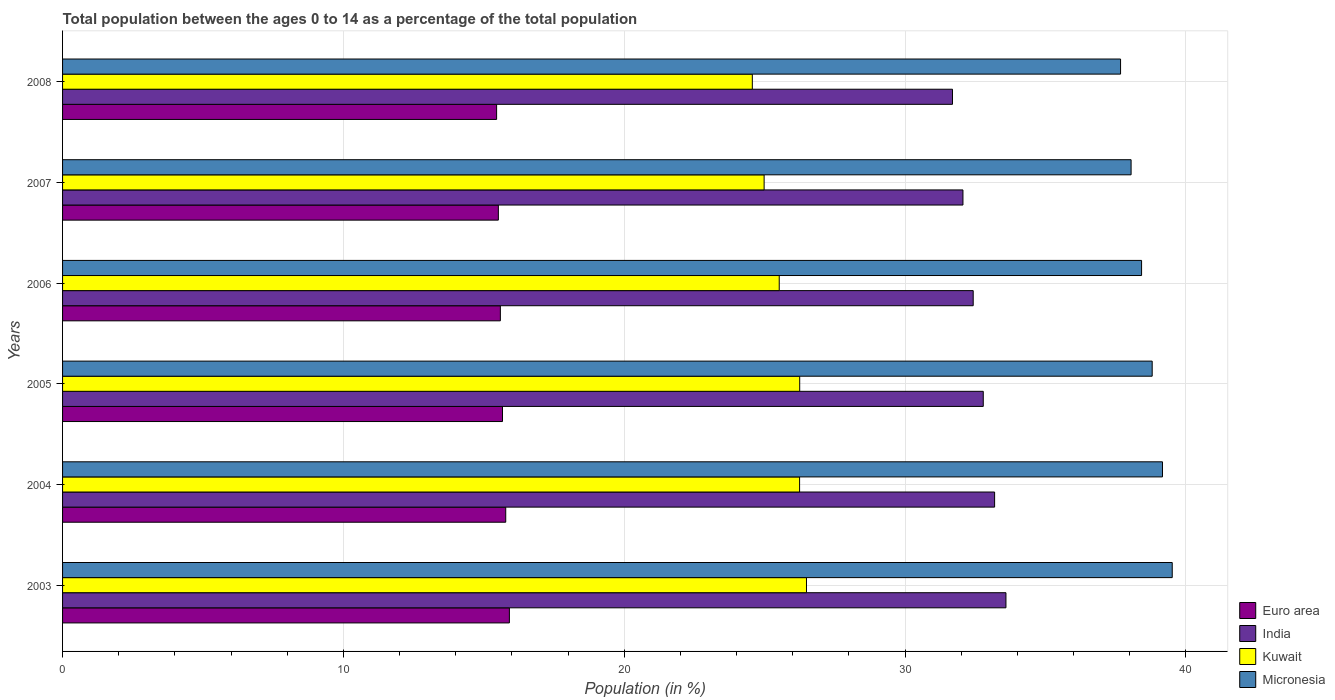How many different coloured bars are there?
Give a very brief answer. 4. How many groups of bars are there?
Keep it short and to the point. 6. Are the number of bars on each tick of the Y-axis equal?
Your answer should be compact. Yes. What is the label of the 6th group of bars from the top?
Your answer should be very brief. 2003. In how many cases, is the number of bars for a given year not equal to the number of legend labels?
Your answer should be compact. 0. What is the percentage of the population ages 0 to 14 in Euro area in 2003?
Ensure brevity in your answer.  15.91. Across all years, what is the maximum percentage of the population ages 0 to 14 in Euro area?
Ensure brevity in your answer.  15.91. Across all years, what is the minimum percentage of the population ages 0 to 14 in Kuwait?
Provide a succinct answer. 24.56. In which year was the percentage of the population ages 0 to 14 in Kuwait minimum?
Make the answer very short. 2008. What is the total percentage of the population ages 0 to 14 in Kuwait in the graph?
Your answer should be very brief. 154.05. What is the difference between the percentage of the population ages 0 to 14 in Euro area in 2004 and that in 2005?
Provide a succinct answer. 0.12. What is the difference between the percentage of the population ages 0 to 14 in Euro area in 2005 and the percentage of the population ages 0 to 14 in India in 2003?
Your answer should be very brief. -17.93. What is the average percentage of the population ages 0 to 14 in India per year?
Your answer should be compact. 32.62. In the year 2008, what is the difference between the percentage of the population ages 0 to 14 in India and percentage of the population ages 0 to 14 in Kuwait?
Keep it short and to the point. 7.13. In how many years, is the percentage of the population ages 0 to 14 in Kuwait greater than 4 ?
Your response must be concise. 6. What is the ratio of the percentage of the population ages 0 to 14 in Euro area in 2007 to that in 2008?
Your response must be concise. 1. Is the percentage of the population ages 0 to 14 in Euro area in 2003 less than that in 2004?
Give a very brief answer. No. What is the difference between the highest and the second highest percentage of the population ages 0 to 14 in Kuwait?
Provide a succinct answer. 0.24. What is the difference between the highest and the lowest percentage of the population ages 0 to 14 in India?
Keep it short and to the point. 1.9. Is it the case that in every year, the sum of the percentage of the population ages 0 to 14 in Kuwait and percentage of the population ages 0 to 14 in Euro area is greater than the sum of percentage of the population ages 0 to 14 in India and percentage of the population ages 0 to 14 in Micronesia?
Your answer should be very brief. No. What does the 2nd bar from the top in 2006 represents?
Provide a succinct answer. Kuwait. What does the 4th bar from the bottom in 2005 represents?
Provide a succinct answer. Micronesia. How many bars are there?
Offer a very short reply. 24. Are all the bars in the graph horizontal?
Ensure brevity in your answer.  Yes. What is the difference between two consecutive major ticks on the X-axis?
Offer a very short reply. 10. Does the graph contain any zero values?
Offer a very short reply. No. What is the title of the graph?
Provide a short and direct response. Total population between the ages 0 to 14 as a percentage of the total population. What is the Population (in %) in Euro area in 2003?
Ensure brevity in your answer.  15.91. What is the Population (in %) of India in 2003?
Offer a very short reply. 33.59. What is the Population (in %) of Kuwait in 2003?
Offer a very short reply. 26.49. What is the Population (in %) in Micronesia in 2003?
Your response must be concise. 39.51. What is the Population (in %) of Euro area in 2004?
Offer a terse response. 15.78. What is the Population (in %) in India in 2004?
Keep it short and to the point. 33.19. What is the Population (in %) of Kuwait in 2004?
Provide a short and direct response. 26.24. What is the Population (in %) in Micronesia in 2004?
Offer a terse response. 39.17. What is the Population (in %) in Euro area in 2005?
Ensure brevity in your answer.  15.67. What is the Population (in %) of India in 2005?
Provide a succinct answer. 32.78. What is the Population (in %) of Kuwait in 2005?
Provide a short and direct response. 26.25. What is the Population (in %) of Micronesia in 2005?
Make the answer very short. 38.8. What is the Population (in %) of Euro area in 2006?
Give a very brief answer. 15.59. What is the Population (in %) of India in 2006?
Provide a succinct answer. 32.43. What is the Population (in %) of Kuwait in 2006?
Your response must be concise. 25.52. What is the Population (in %) of Micronesia in 2006?
Give a very brief answer. 38.42. What is the Population (in %) of Euro area in 2007?
Ensure brevity in your answer.  15.52. What is the Population (in %) in India in 2007?
Provide a succinct answer. 32.06. What is the Population (in %) in Kuwait in 2007?
Ensure brevity in your answer.  24.98. What is the Population (in %) in Micronesia in 2007?
Offer a terse response. 38.05. What is the Population (in %) in Euro area in 2008?
Your answer should be very brief. 15.46. What is the Population (in %) of India in 2008?
Ensure brevity in your answer.  31.69. What is the Population (in %) of Kuwait in 2008?
Keep it short and to the point. 24.56. What is the Population (in %) of Micronesia in 2008?
Offer a terse response. 37.67. Across all years, what is the maximum Population (in %) of Euro area?
Ensure brevity in your answer.  15.91. Across all years, what is the maximum Population (in %) in India?
Provide a succinct answer. 33.59. Across all years, what is the maximum Population (in %) in Kuwait?
Ensure brevity in your answer.  26.49. Across all years, what is the maximum Population (in %) of Micronesia?
Offer a terse response. 39.51. Across all years, what is the minimum Population (in %) of Euro area?
Your response must be concise. 15.46. Across all years, what is the minimum Population (in %) of India?
Ensure brevity in your answer.  31.69. Across all years, what is the minimum Population (in %) in Kuwait?
Offer a very short reply. 24.56. Across all years, what is the minimum Population (in %) of Micronesia?
Provide a short and direct response. 37.67. What is the total Population (in %) in Euro area in the graph?
Offer a very short reply. 93.92. What is the total Population (in %) in India in the graph?
Provide a succinct answer. 195.74. What is the total Population (in %) of Kuwait in the graph?
Provide a short and direct response. 154.05. What is the total Population (in %) in Micronesia in the graph?
Ensure brevity in your answer.  231.63. What is the difference between the Population (in %) in Euro area in 2003 and that in 2004?
Your response must be concise. 0.13. What is the difference between the Population (in %) in India in 2003 and that in 2004?
Make the answer very short. 0.4. What is the difference between the Population (in %) in Kuwait in 2003 and that in 2004?
Offer a very short reply. 0.25. What is the difference between the Population (in %) of Micronesia in 2003 and that in 2004?
Provide a short and direct response. 0.35. What is the difference between the Population (in %) in Euro area in 2003 and that in 2005?
Provide a succinct answer. 0.25. What is the difference between the Population (in %) in India in 2003 and that in 2005?
Keep it short and to the point. 0.81. What is the difference between the Population (in %) of Kuwait in 2003 and that in 2005?
Provide a succinct answer. 0.24. What is the difference between the Population (in %) of Micronesia in 2003 and that in 2005?
Provide a succinct answer. 0.71. What is the difference between the Population (in %) of Euro area in 2003 and that in 2006?
Provide a short and direct response. 0.32. What is the difference between the Population (in %) in India in 2003 and that in 2006?
Your answer should be very brief. 1.17. What is the difference between the Population (in %) in Kuwait in 2003 and that in 2006?
Give a very brief answer. 0.97. What is the difference between the Population (in %) of Micronesia in 2003 and that in 2006?
Provide a succinct answer. 1.09. What is the difference between the Population (in %) of Euro area in 2003 and that in 2007?
Ensure brevity in your answer.  0.39. What is the difference between the Population (in %) in India in 2003 and that in 2007?
Give a very brief answer. 1.53. What is the difference between the Population (in %) of Kuwait in 2003 and that in 2007?
Ensure brevity in your answer.  1.51. What is the difference between the Population (in %) of Micronesia in 2003 and that in 2007?
Provide a short and direct response. 1.46. What is the difference between the Population (in %) of Euro area in 2003 and that in 2008?
Your answer should be very brief. 0.46. What is the difference between the Population (in %) of India in 2003 and that in 2008?
Provide a short and direct response. 1.9. What is the difference between the Population (in %) in Kuwait in 2003 and that in 2008?
Provide a succinct answer. 1.93. What is the difference between the Population (in %) in Micronesia in 2003 and that in 2008?
Your response must be concise. 1.84. What is the difference between the Population (in %) in Euro area in 2004 and that in 2005?
Make the answer very short. 0.12. What is the difference between the Population (in %) of India in 2004 and that in 2005?
Your answer should be compact. 0.4. What is the difference between the Population (in %) in Kuwait in 2004 and that in 2005?
Your response must be concise. -0. What is the difference between the Population (in %) of Micronesia in 2004 and that in 2005?
Offer a terse response. 0.37. What is the difference between the Population (in %) of Euro area in 2004 and that in 2006?
Give a very brief answer. 0.19. What is the difference between the Population (in %) of India in 2004 and that in 2006?
Offer a very short reply. 0.76. What is the difference between the Population (in %) in Kuwait in 2004 and that in 2006?
Your response must be concise. 0.73. What is the difference between the Population (in %) in Micronesia in 2004 and that in 2006?
Offer a very short reply. 0.74. What is the difference between the Population (in %) in Euro area in 2004 and that in 2007?
Keep it short and to the point. 0.26. What is the difference between the Population (in %) of India in 2004 and that in 2007?
Provide a succinct answer. 1.13. What is the difference between the Population (in %) of Kuwait in 2004 and that in 2007?
Keep it short and to the point. 1.26. What is the difference between the Population (in %) of Micronesia in 2004 and that in 2007?
Offer a terse response. 1.12. What is the difference between the Population (in %) of Euro area in 2004 and that in 2008?
Provide a succinct answer. 0.33. What is the difference between the Population (in %) in India in 2004 and that in 2008?
Your answer should be compact. 1.5. What is the difference between the Population (in %) in Kuwait in 2004 and that in 2008?
Your answer should be compact. 1.68. What is the difference between the Population (in %) of Micronesia in 2004 and that in 2008?
Make the answer very short. 1.49. What is the difference between the Population (in %) in Euro area in 2005 and that in 2006?
Offer a terse response. 0.08. What is the difference between the Population (in %) of India in 2005 and that in 2006?
Your response must be concise. 0.36. What is the difference between the Population (in %) in Kuwait in 2005 and that in 2006?
Your answer should be very brief. 0.73. What is the difference between the Population (in %) of Micronesia in 2005 and that in 2006?
Offer a terse response. 0.38. What is the difference between the Population (in %) of Euro area in 2005 and that in 2007?
Make the answer very short. 0.15. What is the difference between the Population (in %) in India in 2005 and that in 2007?
Your answer should be very brief. 0.72. What is the difference between the Population (in %) in Kuwait in 2005 and that in 2007?
Keep it short and to the point. 1.27. What is the difference between the Population (in %) of Micronesia in 2005 and that in 2007?
Offer a terse response. 0.75. What is the difference between the Population (in %) of Euro area in 2005 and that in 2008?
Your answer should be compact. 0.21. What is the difference between the Population (in %) of India in 2005 and that in 2008?
Your response must be concise. 1.1. What is the difference between the Population (in %) in Kuwait in 2005 and that in 2008?
Ensure brevity in your answer.  1.69. What is the difference between the Population (in %) of Micronesia in 2005 and that in 2008?
Give a very brief answer. 1.13. What is the difference between the Population (in %) of Euro area in 2006 and that in 2007?
Your answer should be very brief. 0.07. What is the difference between the Population (in %) of India in 2006 and that in 2007?
Offer a terse response. 0.36. What is the difference between the Population (in %) of Kuwait in 2006 and that in 2007?
Your answer should be very brief. 0.54. What is the difference between the Population (in %) of Micronesia in 2006 and that in 2007?
Provide a succinct answer. 0.37. What is the difference between the Population (in %) in Euro area in 2006 and that in 2008?
Offer a very short reply. 0.13. What is the difference between the Population (in %) in India in 2006 and that in 2008?
Offer a terse response. 0.74. What is the difference between the Population (in %) in Kuwait in 2006 and that in 2008?
Ensure brevity in your answer.  0.96. What is the difference between the Population (in %) of Micronesia in 2006 and that in 2008?
Offer a terse response. 0.75. What is the difference between the Population (in %) of Euro area in 2007 and that in 2008?
Your answer should be compact. 0.06. What is the difference between the Population (in %) in India in 2007 and that in 2008?
Your answer should be very brief. 0.37. What is the difference between the Population (in %) of Kuwait in 2007 and that in 2008?
Keep it short and to the point. 0.42. What is the difference between the Population (in %) of Micronesia in 2007 and that in 2008?
Provide a succinct answer. 0.37. What is the difference between the Population (in %) in Euro area in 2003 and the Population (in %) in India in 2004?
Provide a succinct answer. -17.28. What is the difference between the Population (in %) in Euro area in 2003 and the Population (in %) in Kuwait in 2004?
Offer a very short reply. -10.33. What is the difference between the Population (in %) of Euro area in 2003 and the Population (in %) of Micronesia in 2004?
Provide a succinct answer. -23.26. What is the difference between the Population (in %) of India in 2003 and the Population (in %) of Kuwait in 2004?
Your answer should be compact. 7.35. What is the difference between the Population (in %) of India in 2003 and the Population (in %) of Micronesia in 2004?
Provide a succinct answer. -5.57. What is the difference between the Population (in %) in Kuwait in 2003 and the Population (in %) in Micronesia in 2004?
Your answer should be compact. -12.68. What is the difference between the Population (in %) in Euro area in 2003 and the Population (in %) in India in 2005?
Provide a short and direct response. -16.87. What is the difference between the Population (in %) in Euro area in 2003 and the Population (in %) in Kuwait in 2005?
Your response must be concise. -10.34. What is the difference between the Population (in %) in Euro area in 2003 and the Population (in %) in Micronesia in 2005?
Keep it short and to the point. -22.89. What is the difference between the Population (in %) of India in 2003 and the Population (in %) of Kuwait in 2005?
Keep it short and to the point. 7.34. What is the difference between the Population (in %) of India in 2003 and the Population (in %) of Micronesia in 2005?
Keep it short and to the point. -5.21. What is the difference between the Population (in %) in Kuwait in 2003 and the Population (in %) in Micronesia in 2005?
Offer a very short reply. -12.31. What is the difference between the Population (in %) of Euro area in 2003 and the Population (in %) of India in 2006?
Ensure brevity in your answer.  -16.52. What is the difference between the Population (in %) in Euro area in 2003 and the Population (in %) in Kuwait in 2006?
Provide a succinct answer. -9.61. What is the difference between the Population (in %) of Euro area in 2003 and the Population (in %) of Micronesia in 2006?
Offer a very short reply. -22.51. What is the difference between the Population (in %) of India in 2003 and the Population (in %) of Kuwait in 2006?
Your answer should be very brief. 8.07. What is the difference between the Population (in %) of India in 2003 and the Population (in %) of Micronesia in 2006?
Your answer should be compact. -4.83. What is the difference between the Population (in %) in Kuwait in 2003 and the Population (in %) in Micronesia in 2006?
Your answer should be very brief. -11.93. What is the difference between the Population (in %) in Euro area in 2003 and the Population (in %) in India in 2007?
Provide a short and direct response. -16.15. What is the difference between the Population (in %) in Euro area in 2003 and the Population (in %) in Kuwait in 2007?
Make the answer very short. -9.07. What is the difference between the Population (in %) of Euro area in 2003 and the Population (in %) of Micronesia in 2007?
Give a very brief answer. -22.14. What is the difference between the Population (in %) in India in 2003 and the Population (in %) in Kuwait in 2007?
Make the answer very short. 8.61. What is the difference between the Population (in %) in India in 2003 and the Population (in %) in Micronesia in 2007?
Your answer should be compact. -4.46. What is the difference between the Population (in %) in Kuwait in 2003 and the Population (in %) in Micronesia in 2007?
Ensure brevity in your answer.  -11.56. What is the difference between the Population (in %) in Euro area in 2003 and the Population (in %) in India in 2008?
Provide a succinct answer. -15.78. What is the difference between the Population (in %) of Euro area in 2003 and the Population (in %) of Kuwait in 2008?
Your answer should be compact. -8.65. What is the difference between the Population (in %) of Euro area in 2003 and the Population (in %) of Micronesia in 2008?
Your answer should be very brief. -21.76. What is the difference between the Population (in %) in India in 2003 and the Population (in %) in Kuwait in 2008?
Provide a succinct answer. 9.03. What is the difference between the Population (in %) in India in 2003 and the Population (in %) in Micronesia in 2008?
Provide a short and direct response. -4.08. What is the difference between the Population (in %) of Kuwait in 2003 and the Population (in %) of Micronesia in 2008?
Make the answer very short. -11.18. What is the difference between the Population (in %) of Euro area in 2004 and the Population (in %) of India in 2005?
Your response must be concise. -17. What is the difference between the Population (in %) in Euro area in 2004 and the Population (in %) in Kuwait in 2005?
Offer a terse response. -10.47. What is the difference between the Population (in %) in Euro area in 2004 and the Population (in %) in Micronesia in 2005?
Give a very brief answer. -23.02. What is the difference between the Population (in %) in India in 2004 and the Population (in %) in Kuwait in 2005?
Your answer should be compact. 6.94. What is the difference between the Population (in %) in India in 2004 and the Population (in %) in Micronesia in 2005?
Your answer should be very brief. -5.61. What is the difference between the Population (in %) in Kuwait in 2004 and the Population (in %) in Micronesia in 2005?
Keep it short and to the point. -12.56. What is the difference between the Population (in %) of Euro area in 2004 and the Population (in %) of India in 2006?
Give a very brief answer. -16.65. What is the difference between the Population (in %) in Euro area in 2004 and the Population (in %) in Kuwait in 2006?
Provide a succinct answer. -9.74. What is the difference between the Population (in %) in Euro area in 2004 and the Population (in %) in Micronesia in 2006?
Your answer should be very brief. -22.64. What is the difference between the Population (in %) in India in 2004 and the Population (in %) in Kuwait in 2006?
Give a very brief answer. 7.67. What is the difference between the Population (in %) in India in 2004 and the Population (in %) in Micronesia in 2006?
Give a very brief answer. -5.23. What is the difference between the Population (in %) of Kuwait in 2004 and the Population (in %) of Micronesia in 2006?
Ensure brevity in your answer.  -12.18. What is the difference between the Population (in %) in Euro area in 2004 and the Population (in %) in India in 2007?
Your answer should be compact. -16.28. What is the difference between the Population (in %) of Euro area in 2004 and the Population (in %) of Kuwait in 2007?
Give a very brief answer. -9.2. What is the difference between the Population (in %) of Euro area in 2004 and the Population (in %) of Micronesia in 2007?
Keep it short and to the point. -22.27. What is the difference between the Population (in %) of India in 2004 and the Population (in %) of Kuwait in 2007?
Your answer should be compact. 8.21. What is the difference between the Population (in %) in India in 2004 and the Population (in %) in Micronesia in 2007?
Your response must be concise. -4.86. What is the difference between the Population (in %) of Kuwait in 2004 and the Population (in %) of Micronesia in 2007?
Your response must be concise. -11.8. What is the difference between the Population (in %) in Euro area in 2004 and the Population (in %) in India in 2008?
Your answer should be very brief. -15.91. What is the difference between the Population (in %) of Euro area in 2004 and the Population (in %) of Kuwait in 2008?
Ensure brevity in your answer.  -8.78. What is the difference between the Population (in %) of Euro area in 2004 and the Population (in %) of Micronesia in 2008?
Offer a terse response. -21.89. What is the difference between the Population (in %) in India in 2004 and the Population (in %) in Kuwait in 2008?
Ensure brevity in your answer.  8.63. What is the difference between the Population (in %) in India in 2004 and the Population (in %) in Micronesia in 2008?
Make the answer very short. -4.49. What is the difference between the Population (in %) in Kuwait in 2004 and the Population (in %) in Micronesia in 2008?
Provide a short and direct response. -11.43. What is the difference between the Population (in %) in Euro area in 2005 and the Population (in %) in India in 2006?
Offer a very short reply. -16.76. What is the difference between the Population (in %) in Euro area in 2005 and the Population (in %) in Kuwait in 2006?
Keep it short and to the point. -9.85. What is the difference between the Population (in %) of Euro area in 2005 and the Population (in %) of Micronesia in 2006?
Keep it short and to the point. -22.76. What is the difference between the Population (in %) in India in 2005 and the Population (in %) in Kuwait in 2006?
Keep it short and to the point. 7.27. What is the difference between the Population (in %) in India in 2005 and the Population (in %) in Micronesia in 2006?
Offer a terse response. -5.64. What is the difference between the Population (in %) in Kuwait in 2005 and the Population (in %) in Micronesia in 2006?
Keep it short and to the point. -12.17. What is the difference between the Population (in %) in Euro area in 2005 and the Population (in %) in India in 2007?
Offer a very short reply. -16.4. What is the difference between the Population (in %) of Euro area in 2005 and the Population (in %) of Kuwait in 2007?
Provide a short and direct response. -9.32. What is the difference between the Population (in %) of Euro area in 2005 and the Population (in %) of Micronesia in 2007?
Provide a succinct answer. -22.38. What is the difference between the Population (in %) in India in 2005 and the Population (in %) in Kuwait in 2007?
Ensure brevity in your answer.  7.8. What is the difference between the Population (in %) of India in 2005 and the Population (in %) of Micronesia in 2007?
Provide a succinct answer. -5.26. What is the difference between the Population (in %) of Kuwait in 2005 and the Population (in %) of Micronesia in 2007?
Offer a terse response. -11.8. What is the difference between the Population (in %) in Euro area in 2005 and the Population (in %) in India in 2008?
Offer a very short reply. -16.02. What is the difference between the Population (in %) of Euro area in 2005 and the Population (in %) of Kuwait in 2008?
Your answer should be very brief. -8.9. What is the difference between the Population (in %) of Euro area in 2005 and the Population (in %) of Micronesia in 2008?
Your response must be concise. -22.01. What is the difference between the Population (in %) in India in 2005 and the Population (in %) in Kuwait in 2008?
Your response must be concise. 8.22. What is the difference between the Population (in %) in India in 2005 and the Population (in %) in Micronesia in 2008?
Ensure brevity in your answer.  -4.89. What is the difference between the Population (in %) in Kuwait in 2005 and the Population (in %) in Micronesia in 2008?
Keep it short and to the point. -11.43. What is the difference between the Population (in %) in Euro area in 2006 and the Population (in %) in India in 2007?
Offer a terse response. -16.47. What is the difference between the Population (in %) in Euro area in 2006 and the Population (in %) in Kuwait in 2007?
Provide a succinct answer. -9.39. What is the difference between the Population (in %) of Euro area in 2006 and the Population (in %) of Micronesia in 2007?
Make the answer very short. -22.46. What is the difference between the Population (in %) in India in 2006 and the Population (in %) in Kuwait in 2007?
Offer a very short reply. 7.45. What is the difference between the Population (in %) of India in 2006 and the Population (in %) of Micronesia in 2007?
Your answer should be very brief. -5.62. What is the difference between the Population (in %) in Kuwait in 2006 and the Population (in %) in Micronesia in 2007?
Provide a short and direct response. -12.53. What is the difference between the Population (in %) in Euro area in 2006 and the Population (in %) in India in 2008?
Make the answer very short. -16.1. What is the difference between the Population (in %) of Euro area in 2006 and the Population (in %) of Kuwait in 2008?
Offer a terse response. -8.97. What is the difference between the Population (in %) of Euro area in 2006 and the Population (in %) of Micronesia in 2008?
Your answer should be very brief. -22.09. What is the difference between the Population (in %) of India in 2006 and the Population (in %) of Kuwait in 2008?
Provide a short and direct response. 7.87. What is the difference between the Population (in %) of India in 2006 and the Population (in %) of Micronesia in 2008?
Make the answer very short. -5.25. What is the difference between the Population (in %) in Kuwait in 2006 and the Population (in %) in Micronesia in 2008?
Offer a terse response. -12.15. What is the difference between the Population (in %) of Euro area in 2007 and the Population (in %) of India in 2008?
Make the answer very short. -16.17. What is the difference between the Population (in %) in Euro area in 2007 and the Population (in %) in Kuwait in 2008?
Your response must be concise. -9.04. What is the difference between the Population (in %) in Euro area in 2007 and the Population (in %) in Micronesia in 2008?
Offer a very short reply. -22.16. What is the difference between the Population (in %) of India in 2007 and the Population (in %) of Kuwait in 2008?
Your answer should be very brief. 7.5. What is the difference between the Population (in %) of India in 2007 and the Population (in %) of Micronesia in 2008?
Provide a short and direct response. -5.61. What is the difference between the Population (in %) of Kuwait in 2007 and the Population (in %) of Micronesia in 2008?
Provide a succinct answer. -12.69. What is the average Population (in %) of Euro area per year?
Keep it short and to the point. 15.65. What is the average Population (in %) of India per year?
Provide a succinct answer. 32.62. What is the average Population (in %) in Kuwait per year?
Your answer should be compact. 25.67. What is the average Population (in %) in Micronesia per year?
Make the answer very short. 38.6. In the year 2003, what is the difference between the Population (in %) of Euro area and Population (in %) of India?
Give a very brief answer. -17.68. In the year 2003, what is the difference between the Population (in %) of Euro area and Population (in %) of Kuwait?
Offer a very short reply. -10.58. In the year 2003, what is the difference between the Population (in %) in Euro area and Population (in %) in Micronesia?
Provide a short and direct response. -23.6. In the year 2003, what is the difference between the Population (in %) of India and Population (in %) of Kuwait?
Your response must be concise. 7.1. In the year 2003, what is the difference between the Population (in %) of India and Population (in %) of Micronesia?
Your response must be concise. -5.92. In the year 2003, what is the difference between the Population (in %) of Kuwait and Population (in %) of Micronesia?
Offer a terse response. -13.02. In the year 2004, what is the difference between the Population (in %) in Euro area and Population (in %) in India?
Offer a very short reply. -17.41. In the year 2004, what is the difference between the Population (in %) in Euro area and Population (in %) in Kuwait?
Provide a succinct answer. -10.46. In the year 2004, what is the difference between the Population (in %) in Euro area and Population (in %) in Micronesia?
Offer a terse response. -23.39. In the year 2004, what is the difference between the Population (in %) of India and Population (in %) of Kuwait?
Offer a terse response. 6.94. In the year 2004, what is the difference between the Population (in %) in India and Population (in %) in Micronesia?
Keep it short and to the point. -5.98. In the year 2004, what is the difference between the Population (in %) of Kuwait and Population (in %) of Micronesia?
Provide a short and direct response. -12.92. In the year 2005, what is the difference between the Population (in %) in Euro area and Population (in %) in India?
Your answer should be very brief. -17.12. In the year 2005, what is the difference between the Population (in %) of Euro area and Population (in %) of Kuwait?
Offer a very short reply. -10.58. In the year 2005, what is the difference between the Population (in %) in Euro area and Population (in %) in Micronesia?
Your answer should be very brief. -23.13. In the year 2005, what is the difference between the Population (in %) of India and Population (in %) of Kuwait?
Your response must be concise. 6.54. In the year 2005, what is the difference between the Population (in %) in India and Population (in %) in Micronesia?
Offer a very short reply. -6.02. In the year 2005, what is the difference between the Population (in %) in Kuwait and Population (in %) in Micronesia?
Give a very brief answer. -12.55. In the year 2006, what is the difference between the Population (in %) in Euro area and Population (in %) in India?
Your answer should be compact. -16.84. In the year 2006, what is the difference between the Population (in %) in Euro area and Population (in %) in Kuwait?
Provide a short and direct response. -9.93. In the year 2006, what is the difference between the Population (in %) of Euro area and Population (in %) of Micronesia?
Offer a very short reply. -22.83. In the year 2006, what is the difference between the Population (in %) in India and Population (in %) in Kuwait?
Your response must be concise. 6.91. In the year 2006, what is the difference between the Population (in %) of India and Population (in %) of Micronesia?
Provide a succinct answer. -6. In the year 2006, what is the difference between the Population (in %) in Kuwait and Population (in %) in Micronesia?
Your answer should be very brief. -12.9. In the year 2007, what is the difference between the Population (in %) in Euro area and Population (in %) in India?
Give a very brief answer. -16.54. In the year 2007, what is the difference between the Population (in %) of Euro area and Population (in %) of Kuwait?
Offer a terse response. -9.46. In the year 2007, what is the difference between the Population (in %) in Euro area and Population (in %) in Micronesia?
Give a very brief answer. -22.53. In the year 2007, what is the difference between the Population (in %) in India and Population (in %) in Kuwait?
Your response must be concise. 7.08. In the year 2007, what is the difference between the Population (in %) of India and Population (in %) of Micronesia?
Your answer should be very brief. -5.99. In the year 2007, what is the difference between the Population (in %) in Kuwait and Population (in %) in Micronesia?
Provide a succinct answer. -13.07. In the year 2008, what is the difference between the Population (in %) of Euro area and Population (in %) of India?
Provide a succinct answer. -16.23. In the year 2008, what is the difference between the Population (in %) of Euro area and Population (in %) of Kuwait?
Offer a terse response. -9.11. In the year 2008, what is the difference between the Population (in %) of Euro area and Population (in %) of Micronesia?
Offer a terse response. -22.22. In the year 2008, what is the difference between the Population (in %) of India and Population (in %) of Kuwait?
Your answer should be compact. 7.13. In the year 2008, what is the difference between the Population (in %) in India and Population (in %) in Micronesia?
Provide a succinct answer. -5.99. In the year 2008, what is the difference between the Population (in %) in Kuwait and Population (in %) in Micronesia?
Give a very brief answer. -13.11. What is the ratio of the Population (in %) of Euro area in 2003 to that in 2004?
Provide a short and direct response. 1.01. What is the ratio of the Population (in %) of India in 2003 to that in 2004?
Offer a very short reply. 1.01. What is the ratio of the Population (in %) in Kuwait in 2003 to that in 2004?
Give a very brief answer. 1.01. What is the ratio of the Population (in %) of Micronesia in 2003 to that in 2004?
Your answer should be very brief. 1.01. What is the ratio of the Population (in %) of Euro area in 2003 to that in 2005?
Offer a terse response. 1.02. What is the ratio of the Population (in %) of India in 2003 to that in 2005?
Provide a succinct answer. 1.02. What is the ratio of the Population (in %) of Kuwait in 2003 to that in 2005?
Ensure brevity in your answer.  1.01. What is the ratio of the Population (in %) in Micronesia in 2003 to that in 2005?
Ensure brevity in your answer.  1.02. What is the ratio of the Population (in %) in Euro area in 2003 to that in 2006?
Your response must be concise. 1.02. What is the ratio of the Population (in %) of India in 2003 to that in 2006?
Offer a very short reply. 1.04. What is the ratio of the Population (in %) in Kuwait in 2003 to that in 2006?
Offer a terse response. 1.04. What is the ratio of the Population (in %) of Micronesia in 2003 to that in 2006?
Offer a very short reply. 1.03. What is the ratio of the Population (in %) of Euro area in 2003 to that in 2007?
Provide a succinct answer. 1.03. What is the ratio of the Population (in %) in India in 2003 to that in 2007?
Your answer should be compact. 1.05. What is the ratio of the Population (in %) of Kuwait in 2003 to that in 2007?
Ensure brevity in your answer.  1.06. What is the ratio of the Population (in %) in Micronesia in 2003 to that in 2007?
Offer a very short reply. 1.04. What is the ratio of the Population (in %) of Euro area in 2003 to that in 2008?
Your answer should be compact. 1.03. What is the ratio of the Population (in %) in India in 2003 to that in 2008?
Offer a terse response. 1.06. What is the ratio of the Population (in %) of Kuwait in 2003 to that in 2008?
Make the answer very short. 1.08. What is the ratio of the Population (in %) of Micronesia in 2003 to that in 2008?
Provide a succinct answer. 1.05. What is the ratio of the Population (in %) in Euro area in 2004 to that in 2005?
Ensure brevity in your answer.  1.01. What is the ratio of the Population (in %) of India in 2004 to that in 2005?
Give a very brief answer. 1.01. What is the ratio of the Population (in %) of Micronesia in 2004 to that in 2005?
Offer a very short reply. 1.01. What is the ratio of the Population (in %) in Euro area in 2004 to that in 2006?
Provide a short and direct response. 1.01. What is the ratio of the Population (in %) of India in 2004 to that in 2006?
Provide a succinct answer. 1.02. What is the ratio of the Population (in %) in Kuwait in 2004 to that in 2006?
Your answer should be very brief. 1.03. What is the ratio of the Population (in %) in Micronesia in 2004 to that in 2006?
Make the answer very short. 1.02. What is the ratio of the Population (in %) of Euro area in 2004 to that in 2007?
Give a very brief answer. 1.02. What is the ratio of the Population (in %) in India in 2004 to that in 2007?
Offer a very short reply. 1.04. What is the ratio of the Population (in %) of Kuwait in 2004 to that in 2007?
Offer a terse response. 1.05. What is the ratio of the Population (in %) of Micronesia in 2004 to that in 2007?
Make the answer very short. 1.03. What is the ratio of the Population (in %) of Euro area in 2004 to that in 2008?
Your response must be concise. 1.02. What is the ratio of the Population (in %) in India in 2004 to that in 2008?
Keep it short and to the point. 1.05. What is the ratio of the Population (in %) of Kuwait in 2004 to that in 2008?
Your answer should be very brief. 1.07. What is the ratio of the Population (in %) in Micronesia in 2004 to that in 2008?
Your answer should be compact. 1.04. What is the ratio of the Population (in %) in Kuwait in 2005 to that in 2006?
Provide a succinct answer. 1.03. What is the ratio of the Population (in %) of Micronesia in 2005 to that in 2006?
Keep it short and to the point. 1.01. What is the ratio of the Population (in %) in Euro area in 2005 to that in 2007?
Offer a very short reply. 1.01. What is the ratio of the Population (in %) in India in 2005 to that in 2007?
Your response must be concise. 1.02. What is the ratio of the Population (in %) of Kuwait in 2005 to that in 2007?
Give a very brief answer. 1.05. What is the ratio of the Population (in %) of Micronesia in 2005 to that in 2007?
Your answer should be very brief. 1.02. What is the ratio of the Population (in %) of Euro area in 2005 to that in 2008?
Provide a short and direct response. 1.01. What is the ratio of the Population (in %) of India in 2005 to that in 2008?
Give a very brief answer. 1.03. What is the ratio of the Population (in %) in Kuwait in 2005 to that in 2008?
Make the answer very short. 1.07. What is the ratio of the Population (in %) of Micronesia in 2005 to that in 2008?
Give a very brief answer. 1.03. What is the ratio of the Population (in %) of India in 2006 to that in 2007?
Give a very brief answer. 1.01. What is the ratio of the Population (in %) in Kuwait in 2006 to that in 2007?
Make the answer very short. 1.02. What is the ratio of the Population (in %) of Micronesia in 2006 to that in 2007?
Provide a succinct answer. 1.01. What is the ratio of the Population (in %) of Euro area in 2006 to that in 2008?
Your response must be concise. 1.01. What is the ratio of the Population (in %) of India in 2006 to that in 2008?
Your response must be concise. 1.02. What is the ratio of the Population (in %) of Kuwait in 2006 to that in 2008?
Ensure brevity in your answer.  1.04. What is the ratio of the Population (in %) in Micronesia in 2006 to that in 2008?
Your response must be concise. 1.02. What is the ratio of the Population (in %) in Euro area in 2007 to that in 2008?
Offer a terse response. 1. What is the ratio of the Population (in %) in India in 2007 to that in 2008?
Provide a short and direct response. 1.01. What is the ratio of the Population (in %) in Kuwait in 2007 to that in 2008?
Your answer should be very brief. 1.02. What is the ratio of the Population (in %) of Micronesia in 2007 to that in 2008?
Keep it short and to the point. 1.01. What is the difference between the highest and the second highest Population (in %) in Euro area?
Make the answer very short. 0.13. What is the difference between the highest and the second highest Population (in %) of India?
Your response must be concise. 0.4. What is the difference between the highest and the second highest Population (in %) in Kuwait?
Make the answer very short. 0.24. What is the difference between the highest and the second highest Population (in %) in Micronesia?
Keep it short and to the point. 0.35. What is the difference between the highest and the lowest Population (in %) in Euro area?
Your answer should be very brief. 0.46. What is the difference between the highest and the lowest Population (in %) of India?
Keep it short and to the point. 1.9. What is the difference between the highest and the lowest Population (in %) in Kuwait?
Make the answer very short. 1.93. What is the difference between the highest and the lowest Population (in %) in Micronesia?
Your response must be concise. 1.84. 